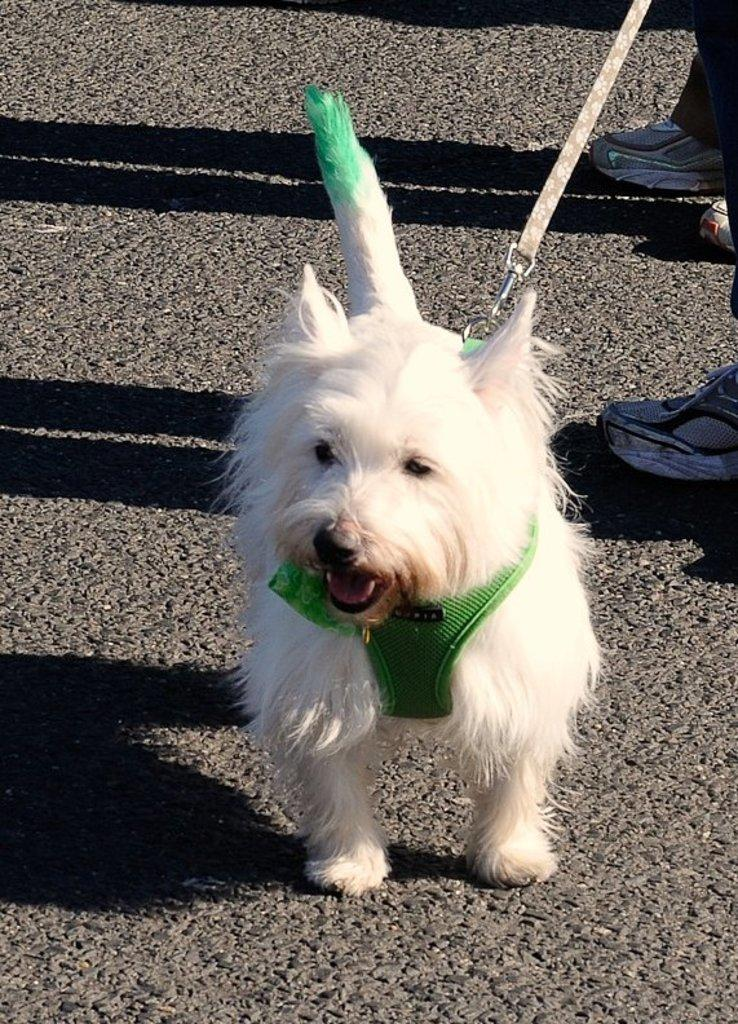What type of animal can be seen in the image? There is a dog in the image. What else is visible in the image besides the dog? There are legs of persons and a belt visible in the image. Can you describe the environment in the image? The scene is on a road. What else can be observed in the image? Shadows are present in the image. What type of notebook is being used by the dog in the image? There is no notebook present in the image, and the dog is not using any object. 